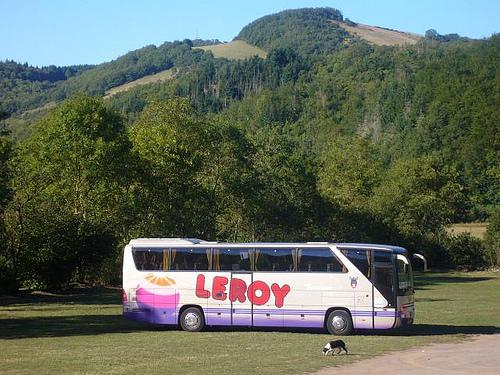Question: what is behind the bus?
Choices:
A. Cars.
B. A hill.
C. A group of school children.
D. A stop sign.
Answer with the letter. Answer: B Question: who is in front of the bus?
Choices:
A. The old lady.
B. The bus driver.
C. A cat.
D. A dog.
Answer with the letter. Answer: D Question: where is the bus?
Choices:
A. On the road.
B. On the grass.
C. In front of the bus stop.
D. By the school.
Answer with the letter. Answer: B Question: how is it parked?
Choices:
A. Facing the road.
B. Behind the school.
C. By the grass.
D. On the shoulder.
Answer with the letter. Answer: A Question: what is written on the bus?
Choices:
A. Jones St..
B. News Nine at Nine.
C. Shop at Frys.
D. Leroy.
Answer with the letter. Answer: D 